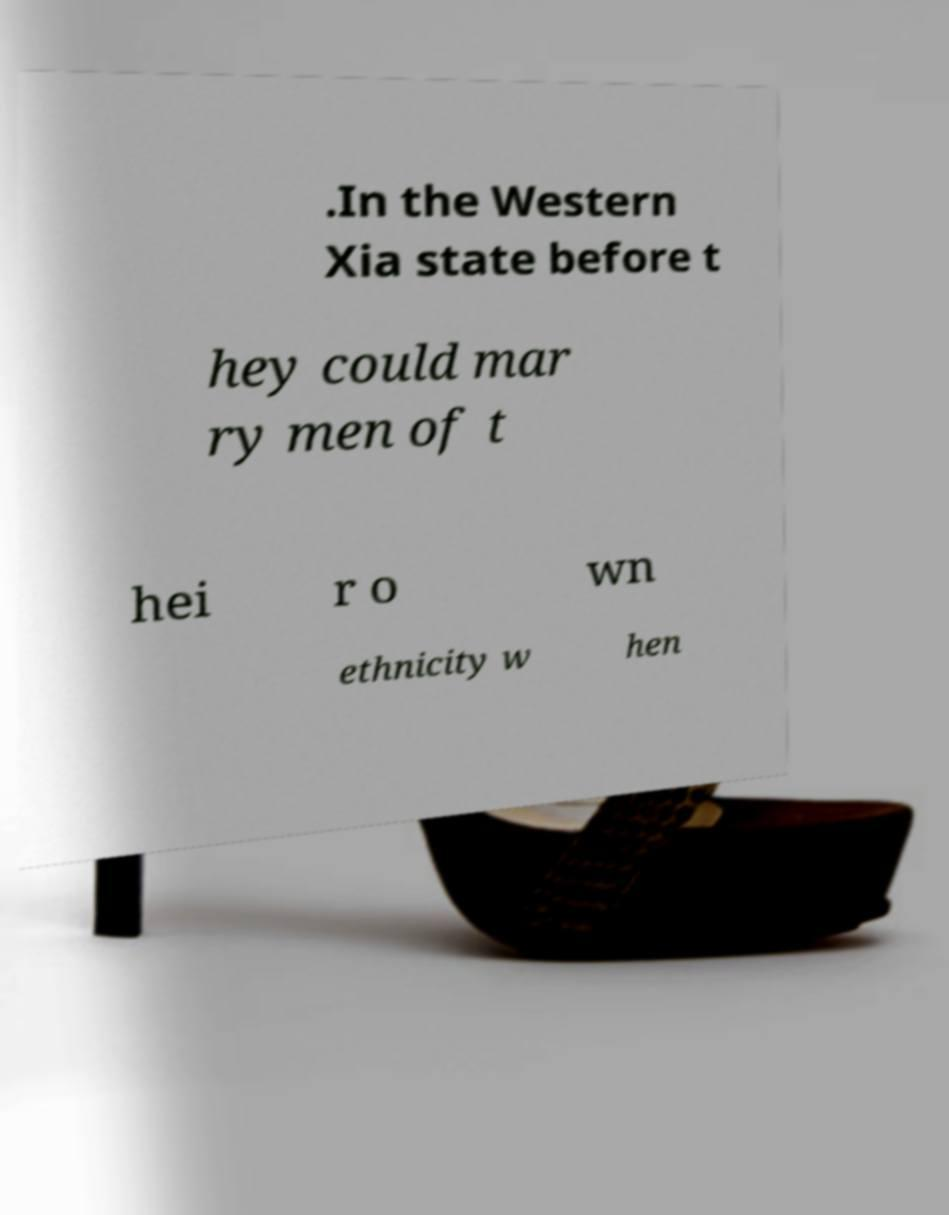For documentation purposes, I need the text within this image transcribed. Could you provide that? .In the Western Xia state before t hey could mar ry men of t hei r o wn ethnicity w hen 